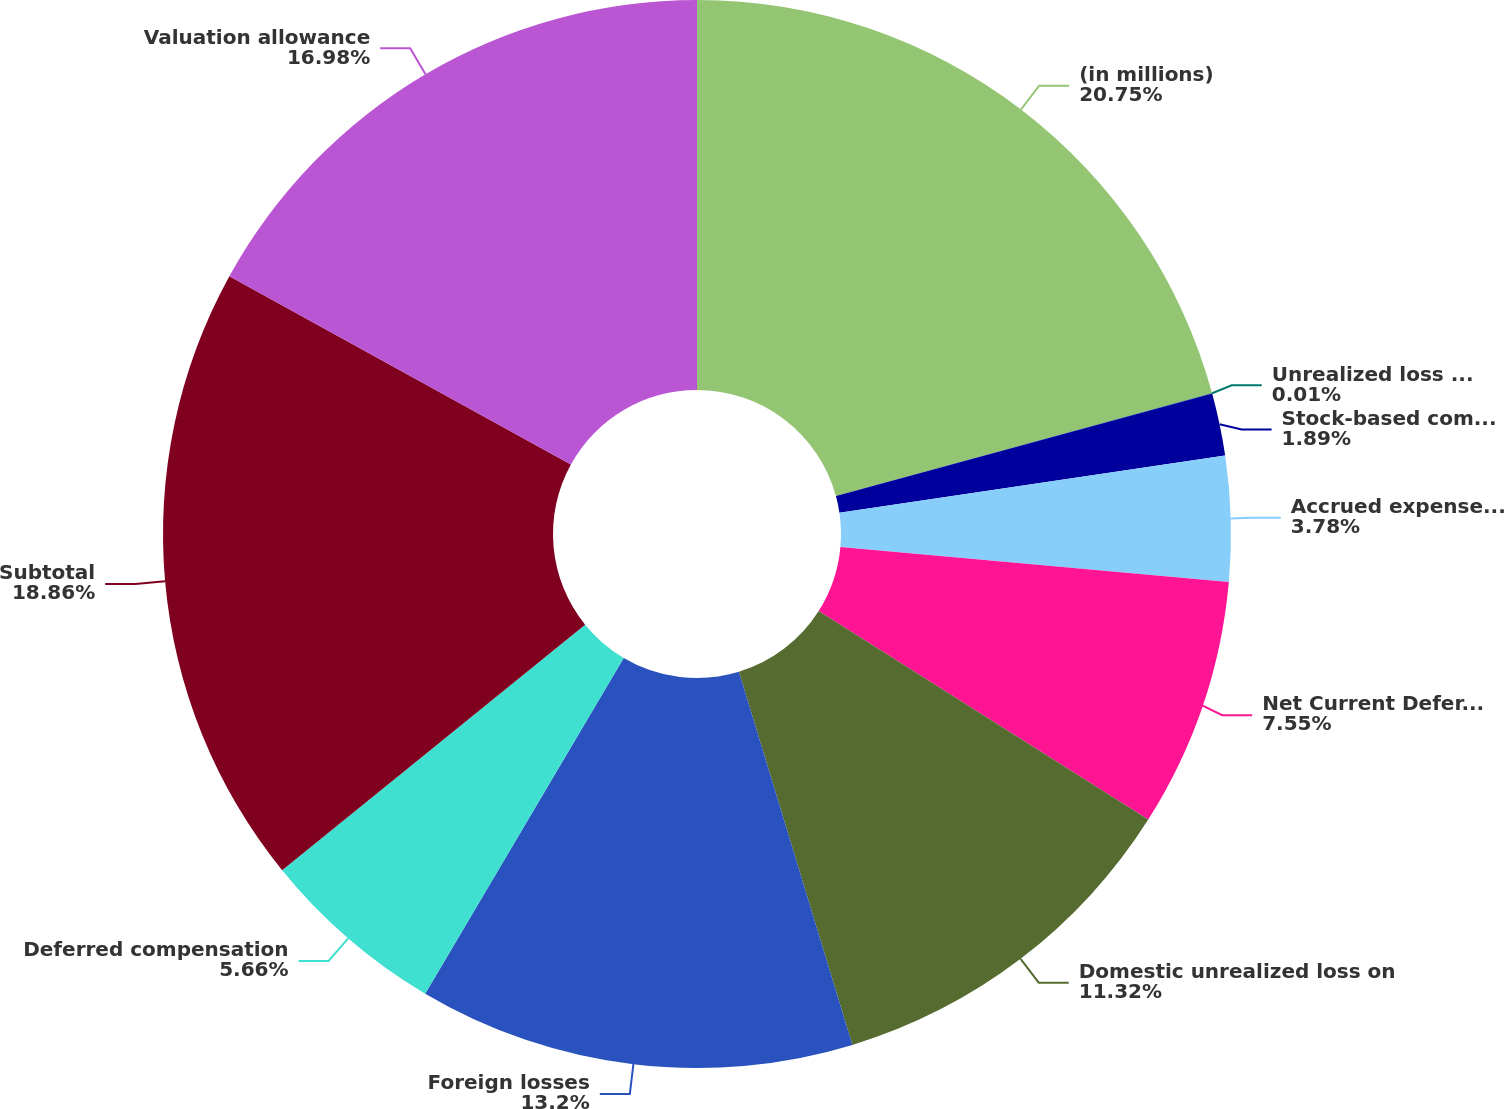<chart> <loc_0><loc_0><loc_500><loc_500><pie_chart><fcel>(in millions)<fcel>Unrealized loss on securities<fcel>Stock-based compensation<fcel>Accrued expenses and other<fcel>Net Current Deferred Tax<fcel>Domestic unrealized loss on<fcel>Foreign losses<fcel>Deferred compensation<fcel>Subtotal<fcel>Valuation allowance<nl><fcel>20.75%<fcel>0.01%<fcel>1.89%<fcel>3.78%<fcel>7.55%<fcel>11.32%<fcel>13.2%<fcel>5.66%<fcel>18.86%<fcel>16.98%<nl></chart> 